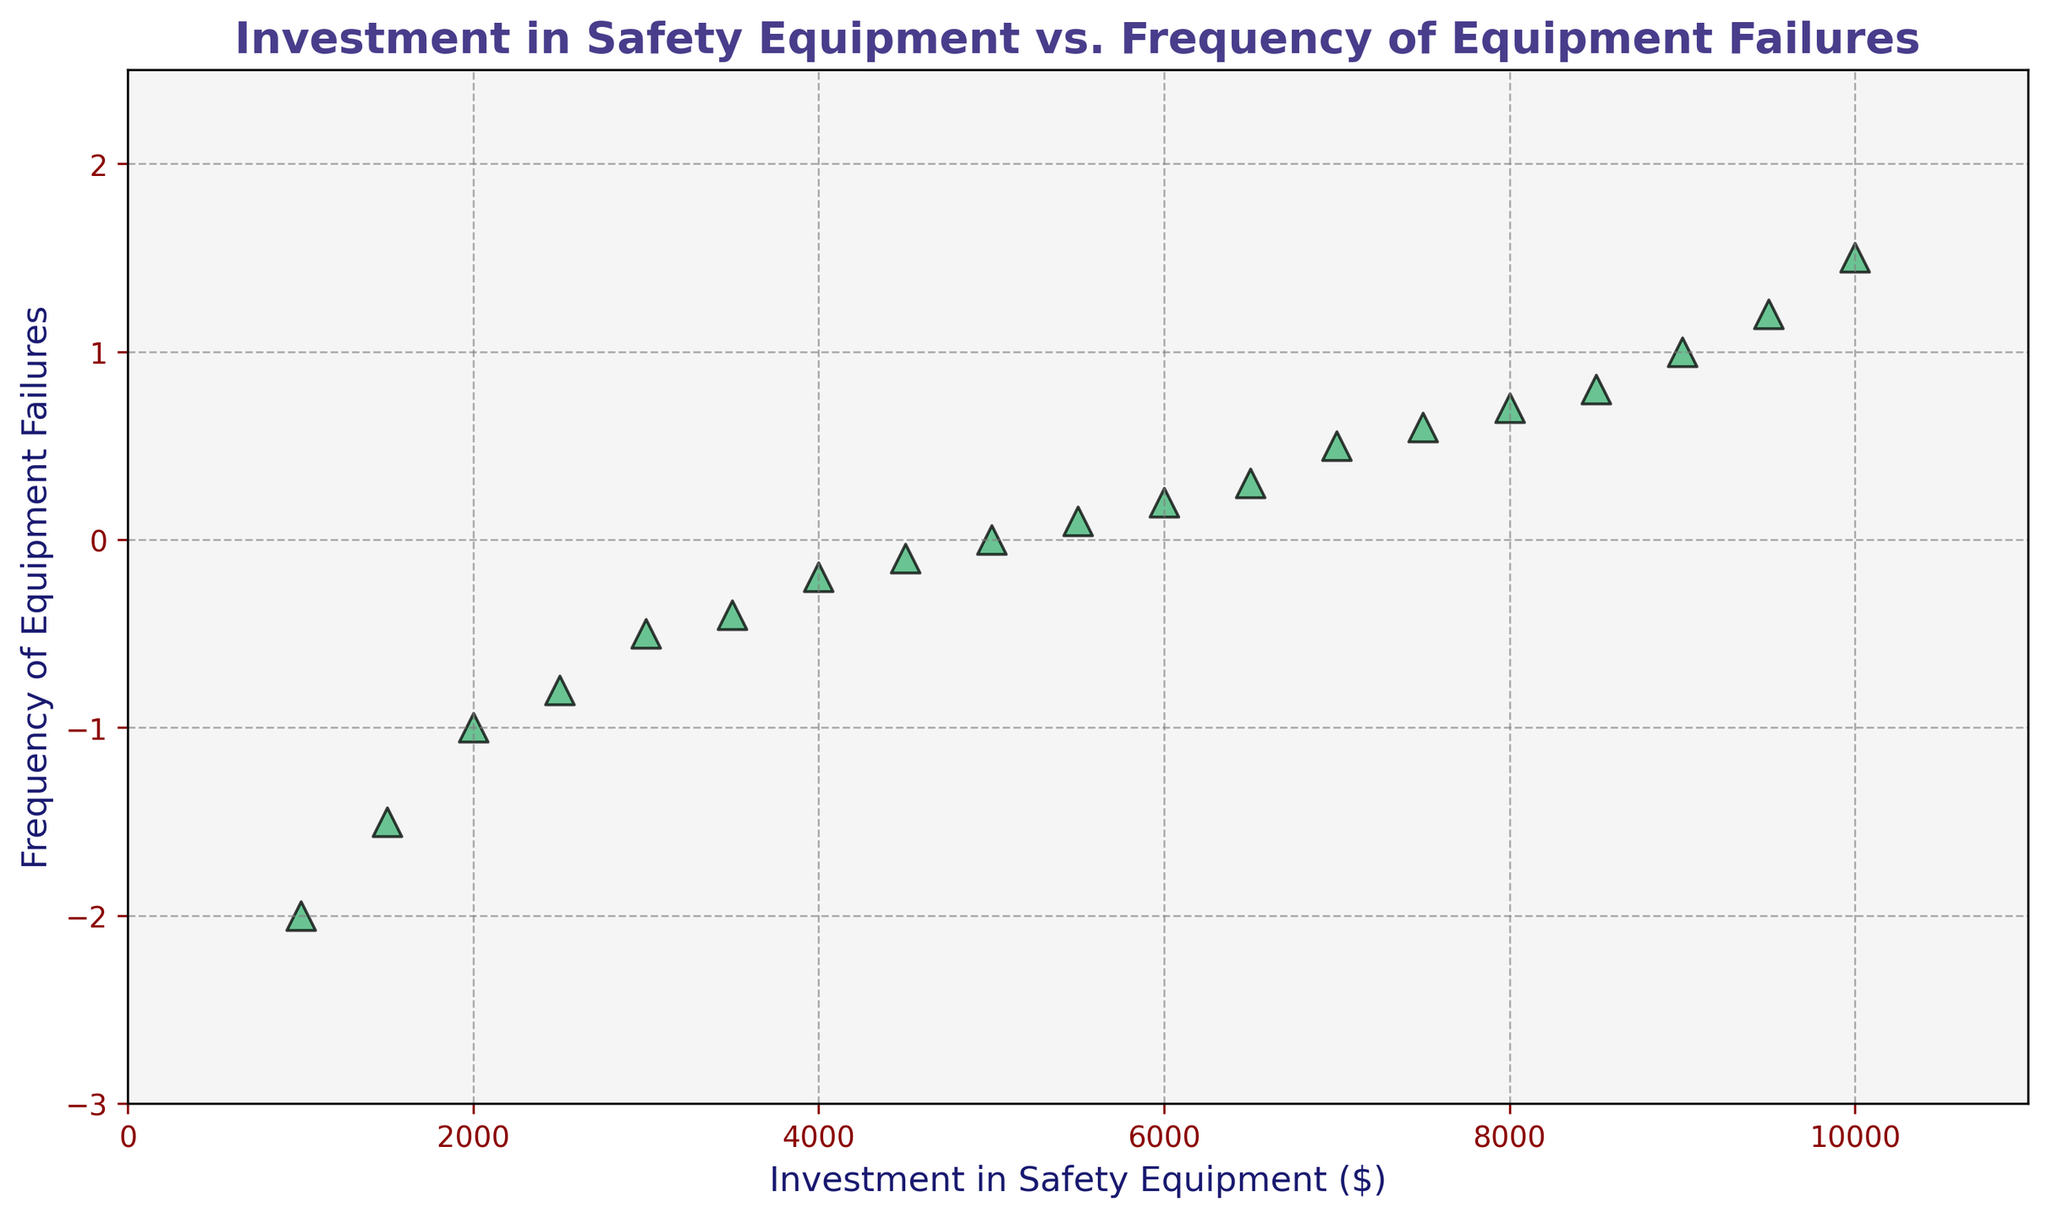What's the relationship between investment in safety equipment and the frequency of equipment failures? If we follow the trend from the scatter plot, as the investment in safety equipment increases, the frequency of equipment failures initially decreases, then starts to increase again. This suggests a non-linear relationship.
Answer: Non-linear relationship At what investment level does the frequency of equipment failures become positive? Observing the scatter plot, the frequency of equipment failures becomes positive at an investment level of $5500.
Answer: $5500 What is the frequency of equipment failures when $8000 is invested in safety equipment? Referring to the scatter plot, at an investment level of $8000, the frequency of equipment failures is around 0.7.
Answer: 0.7 Does investing $9500 reduce equipment failures more than investing $3000? At $9500, the frequency of failures is 1.2, while at $3000 it is -0.5. Between these two points, investing $9500 results in more equipment failures than $3000.
Answer: No By how much does the frequency of equipment failures change between $2000 and $7000 investment? The frequency at $2000 is -1, and at $7000 it is 0.5. The change in frequency of equipment failures is 0.5 - (-1) = 1.5.
Answer: 1.5 Is there a point where increasing investment no longer decreases equipment failures? From observing the plot, initially, increasing investment decreases failures, but after approximately $5000 investment, further increases result in rising failure frequencies.
Answer: Yes Do all positive frequencies occur at higher investments than negative frequencies? Yes, all positive frequencies occur above $5000, while all negative frequencies occur below $5000 based on the scatter plot.
Answer: Yes What is the range of investment levels displayed in the figure? The investment levels range from $1000 to $10000 as shown in the figure's x-axis.
Answer: $1000 to $10000 At what frequency does the plot start showing an increase in the trends of equipment failures? The scatter plot shows an increasing trend in equipment failures beginning approximately around the investment level of $5000, where the frequency is 0.
Answer: 0 What is the lowest frequency of equipment failure observed in the data? The lowest frequency of equipment failure observed is -2, at an investment level of $1000.
Answer: -2 